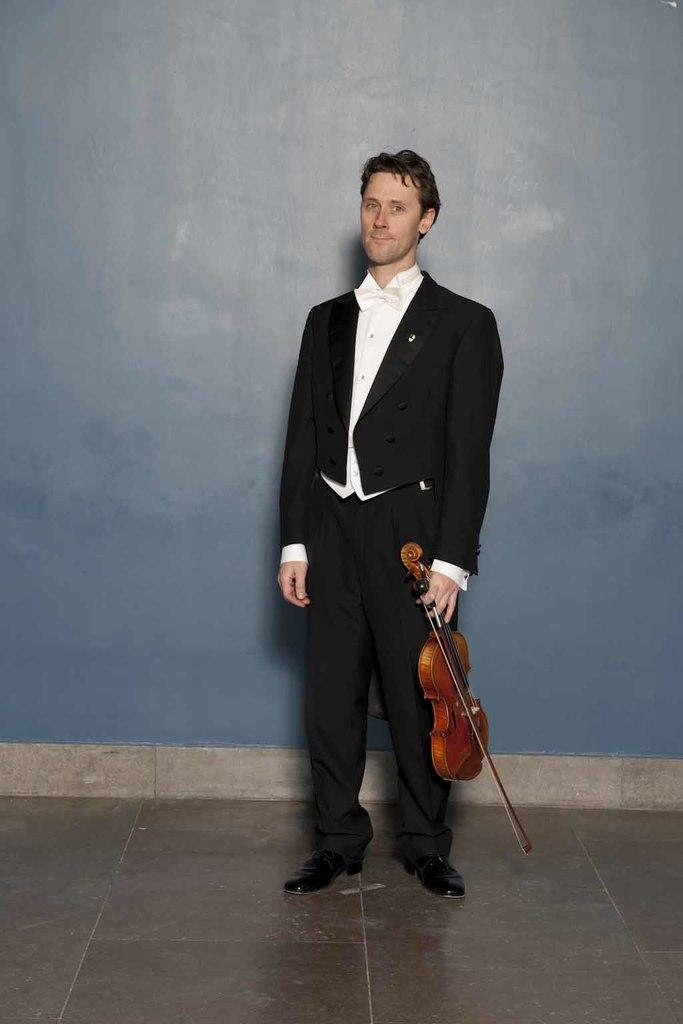What is the main subject of the image? The main subject of the image is a man. What is the man doing in the image? The man is standing in the image. What is the man holding in his hand? The man is holding a musical instrument in his hand. What can be seen in the background of the image? There is a wall in the background of the image. How many mice can be seen running around the man's feet in the image? There are no mice present in the image. What type of writing instrument is the man using to compose a song in the image? The man is not using any writing instrument in the image; he is holding a musical instrument. 